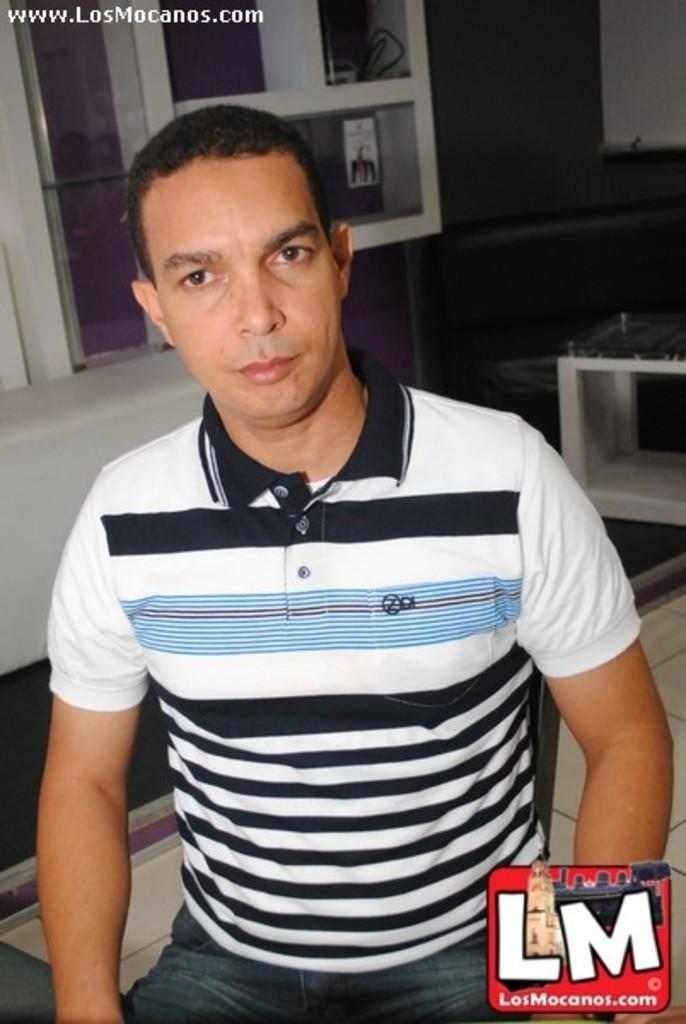<image>
Present a compact description of the photo's key features. A man has uploaded this photograph to www.LosMancos.com. 